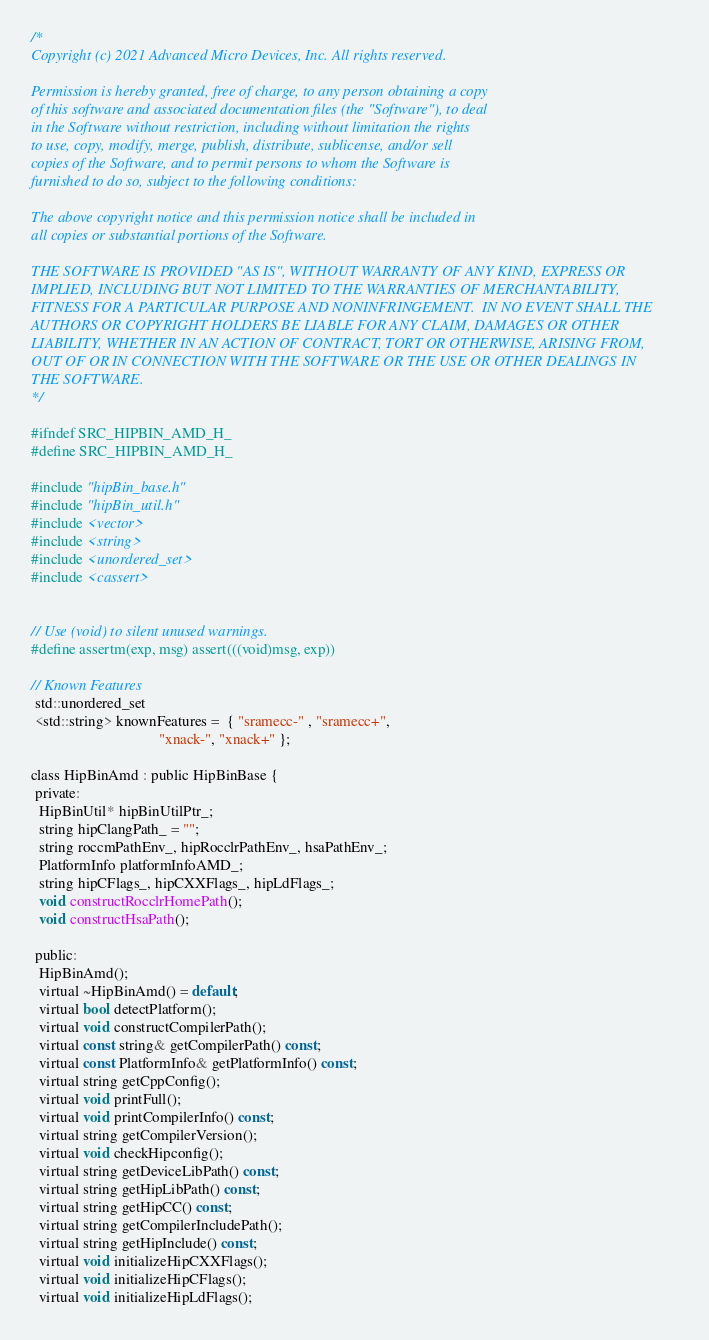Convert code to text. <code><loc_0><loc_0><loc_500><loc_500><_C_>/*
Copyright (c) 2021 Advanced Micro Devices, Inc. All rights reserved.

Permission is hereby granted, free of charge, to any person obtaining a copy
of this software and associated documentation files (the "Software"), to deal
in the Software without restriction, including without limitation the rights
to use, copy, modify, merge, publish, distribute, sublicense, and/or sell
copies of the Software, and to permit persons to whom the Software is
furnished to do so, subject to the following conditions:

The above copyright notice and this permission notice shall be included in
all copies or substantial portions of the Software.

THE SOFTWARE IS PROVIDED "AS IS", WITHOUT WARRANTY OF ANY KIND, EXPRESS OR
IMPLIED, INCLUDING BUT NOT LIMITED TO THE WARRANTIES OF MERCHANTABILITY,
FITNESS FOR A PARTICULAR PURPOSE AND NONINFRINGEMENT.  IN NO EVENT SHALL THE
AUTHORS OR COPYRIGHT HOLDERS BE LIABLE FOR ANY CLAIM, DAMAGES OR OTHER
LIABILITY, WHETHER IN AN ACTION OF CONTRACT, TORT OR OTHERWISE, ARISING FROM,
OUT OF OR IN CONNECTION WITH THE SOFTWARE OR THE USE OR OTHER DEALINGS IN
THE SOFTWARE.
*/

#ifndef SRC_HIPBIN_AMD_H_
#define SRC_HIPBIN_AMD_H_

#include "hipBin_base.h"
#include "hipBin_util.h"
#include <vector>
#include <string>
#include <unordered_set>
#include <cassert>


// Use (void) to silent unused warnings.
#define assertm(exp, msg) assert(((void)msg, exp))

// Known Features
 std::unordered_set
 <std::string> knownFeatures =  { "sramecc-" , "sramecc+",
                                  "xnack-", "xnack+" };

class HipBinAmd : public HipBinBase {
 private:
  HipBinUtil* hipBinUtilPtr_;
  string hipClangPath_ = "";
  string roccmPathEnv_, hipRocclrPathEnv_, hsaPathEnv_;
  PlatformInfo platformInfoAMD_;
  string hipCFlags_, hipCXXFlags_, hipLdFlags_;
  void constructRocclrHomePath();
  void constructHsaPath();

 public:
  HipBinAmd();
  virtual ~HipBinAmd() = default;
  virtual bool detectPlatform();
  virtual void constructCompilerPath();
  virtual const string& getCompilerPath() const;
  virtual const PlatformInfo& getPlatformInfo() const;
  virtual string getCppConfig();
  virtual void printFull();
  virtual void printCompilerInfo() const;
  virtual string getCompilerVersion();
  virtual void checkHipconfig();
  virtual string getDeviceLibPath() const;
  virtual string getHipLibPath() const;
  virtual string getHipCC() const;
  virtual string getCompilerIncludePath();
  virtual string getHipInclude() const;
  virtual void initializeHipCXXFlags();
  virtual void initializeHipCFlags();
  virtual void initializeHipLdFlags();</code> 